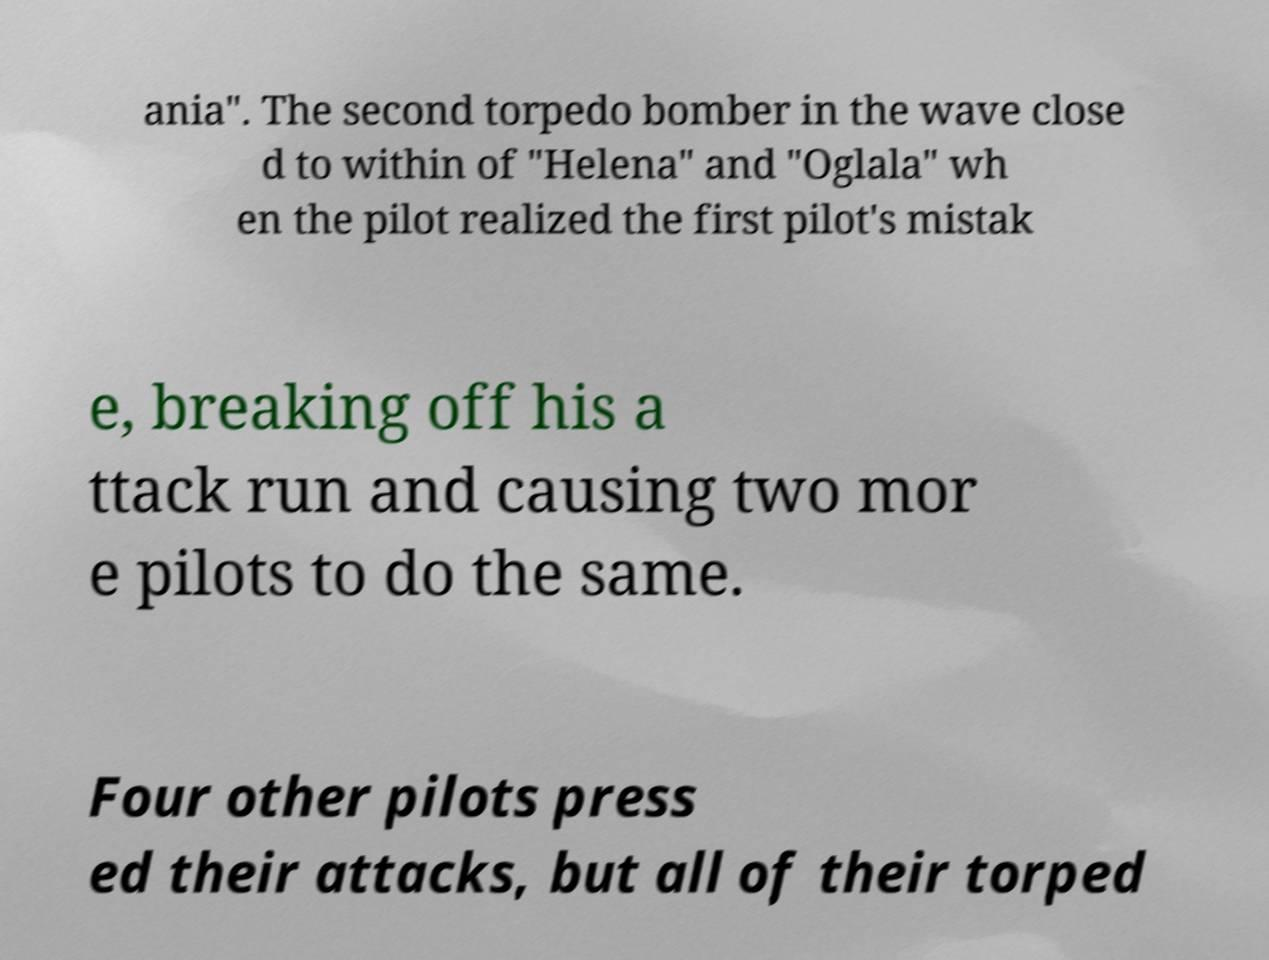Can you read and provide the text displayed in the image?This photo seems to have some interesting text. Can you extract and type it out for me? ania". The second torpedo bomber in the wave close d to within of "Helena" and "Oglala" wh en the pilot realized the first pilot's mistak e, breaking off his a ttack run and causing two mor e pilots to do the same. Four other pilots press ed their attacks, but all of their torped 